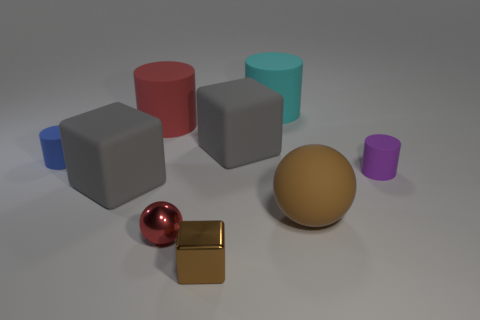Subtract all yellow spheres. Subtract all blue cylinders. How many spheres are left? 2 Subtract all cylinders. How many objects are left? 5 Add 3 large brown things. How many large brown things exist? 4 Subtract 0 cyan balls. How many objects are left? 9 Subtract all large gray rubber cubes. Subtract all big gray objects. How many objects are left? 5 Add 6 small brown shiny objects. How many small brown shiny objects are left? 7 